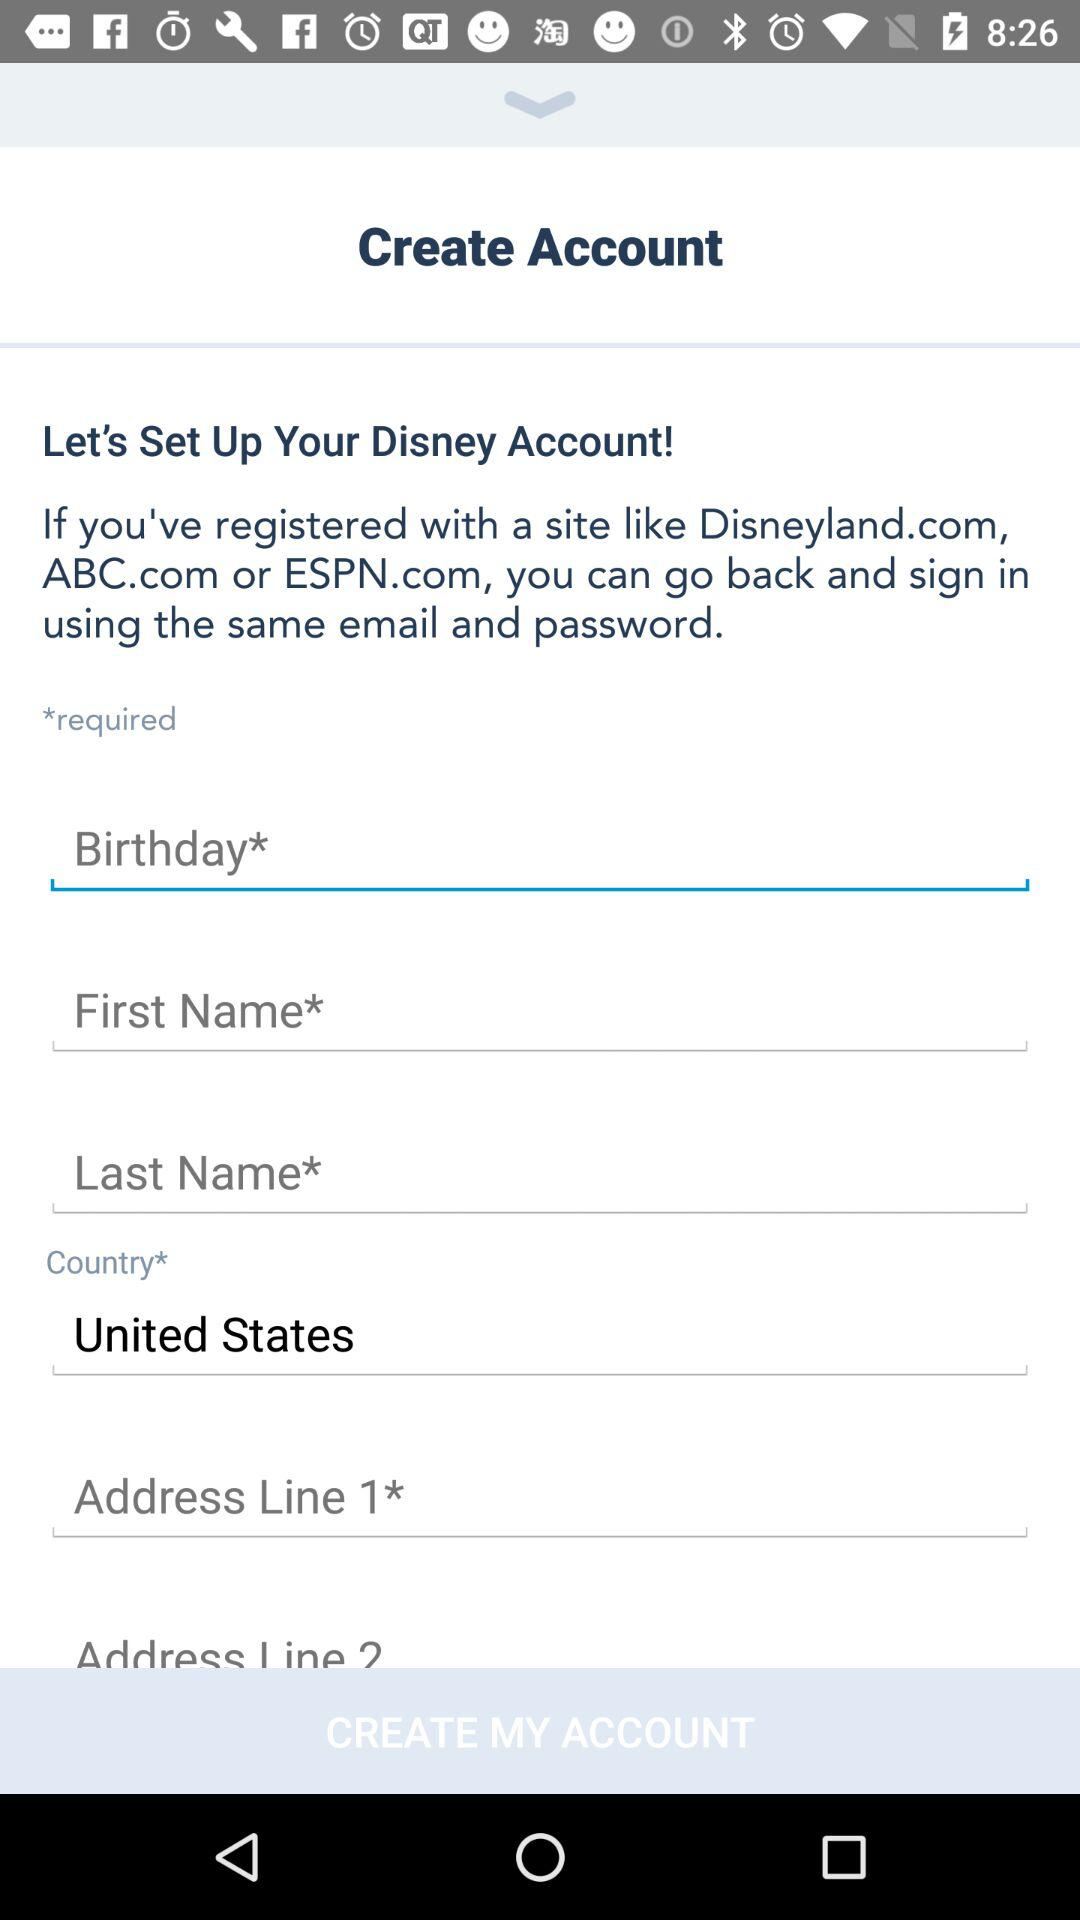How many text inputs require a value? Based on the image provided, a total of five text inputs require a value. They are labeled 'Birthday', 'First Name', 'Last Name', 'Country', and 'Address Line 1', each marked with an asterisk to indicate that they are mandatory for the account creation process. 